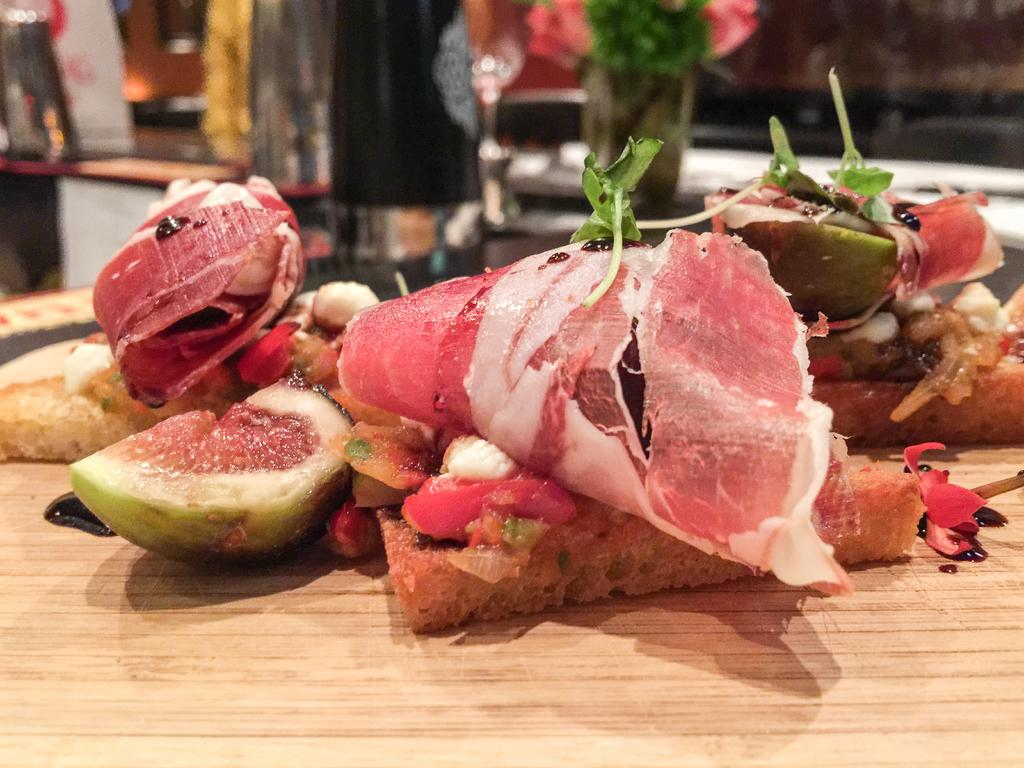What is present on the wooden board in the image? There are food items placed on a wooden board in the image. Can you describe the surface on which the food items are placed? The food items are placed on a wooden board. What can be seen in the background of the image? There are objects in the background of the image. How would you describe the clarity of the objects in the background? The objects in the background appear slightly blurred. What is the name of the heart-shaped food item in the image? There is no heart-shaped food item present in the image. 